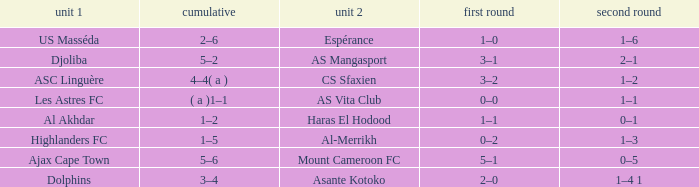What is the 2nd leg of team 1 Dolphins? 1–4 1. 